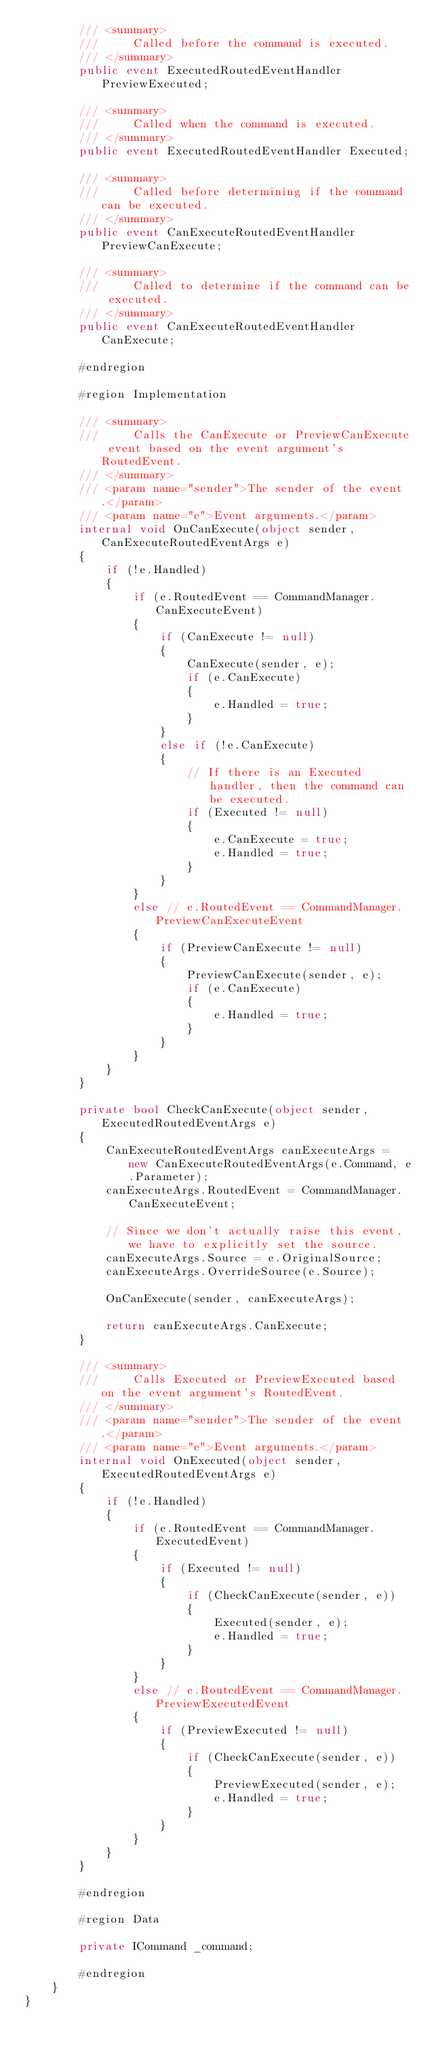Convert code to text. <code><loc_0><loc_0><loc_500><loc_500><_C#_>        /// <summary>
        ///     Called before the command is executed.
        /// </summary>
        public event ExecutedRoutedEventHandler PreviewExecuted;

        /// <summary>
        ///     Called when the command is executed.
        /// </summary>
        public event ExecutedRoutedEventHandler Executed;

        /// <summary>
        ///     Called before determining if the command can be executed.
        /// </summary>
        public event CanExecuteRoutedEventHandler PreviewCanExecute;

        /// <summary>
        ///     Called to determine if the command can be executed.
        /// </summary>
        public event CanExecuteRoutedEventHandler CanExecute;

        #endregion

        #region Implementation

        /// <summary>
        ///     Calls the CanExecute or PreviewCanExecute event based on the event argument's RoutedEvent.
        /// </summary>
        /// <param name="sender">The sender of the event.</param>
        /// <param name="e">Event arguments.</param>
        internal void OnCanExecute(object sender, CanExecuteRoutedEventArgs e)
        {
            if (!e.Handled)
            {
                if (e.RoutedEvent == CommandManager.CanExecuteEvent)
                {
                    if (CanExecute != null)
                    {
                        CanExecute(sender, e);
                        if (e.CanExecute)
                        {
                            e.Handled = true;
                        }
                    }
                    else if (!e.CanExecute)
                    {
                        // If there is an Executed handler, then the command can be executed.
                        if (Executed != null)
                        {
                            e.CanExecute = true;
                            e.Handled = true;
                        }
                    }
                }
                else // e.RoutedEvent == CommandManager.PreviewCanExecuteEvent
                {
                    if (PreviewCanExecute != null)
                    {
                        PreviewCanExecute(sender, e);
                        if (e.CanExecute)
                        {
                            e.Handled = true;
                        }
                    }
                }
            }
        }

        private bool CheckCanExecute(object sender, ExecutedRoutedEventArgs e)
        {
            CanExecuteRoutedEventArgs canExecuteArgs = new CanExecuteRoutedEventArgs(e.Command, e.Parameter);
            canExecuteArgs.RoutedEvent = CommandManager.CanExecuteEvent;

            // Since we don't actually raise this event, we have to explicitly set the source.
            canExecuteArgs.Source = e.OriginalSource;
            canExecuteArgs.OverrideSource(e.Source);
            
            OnCanExecute(sender, canExecuteArgs);

            return canExecuteArgs.CanExecute;
        }

        /// <summary>
        ///     Calls Executed or PreviewExecuted based on the event argument's RoutedEvent.
        /// </summary>
        /// <param name="sender">The sender of the event.</param>
        /// <param name="e">Event arguments.</param>
        internal void OnExecuted(object sender, ExecutedRoutedEventArgs e)
        {
            if (!e.Handled)
            {
                if (e.RoutedEvent == CommandManager.ExecutedEvent)
                {
                    if (Executed != null)
                    {
                        if (CheckCanExecute(sender, e))
                        {
                            Executed(sender, e);
                            e.Handled = true;
                        }
                    }
                }
                else // e.RoutedEvent == CommandManager.PreviewExecutedEvent
                {
                    if (PreviewExecuted != null)
                    {
                        if (CheckCanExecute(sender, e))
                        {
                            PreviewExecuted(sender, e);
                            e.Handled = true;
                        }
                    }
                }
            }
        }

        #endregion

        #region Data

        private ICommand _command;

        #endregion
    }
}
</code> 